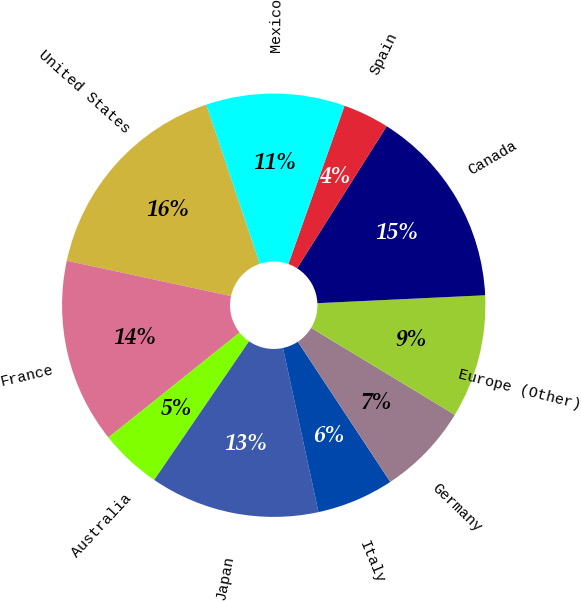<chart> <loc_0><loc_0><loc_500><loc_500><pie_chart><fcel>United States<fcel>France<fcel>Australia<fcel>Japan<fcel>Italy<fcel>Germany<fcel>Europe (Other)<fcel>Canada<fcel>Spain<fcel>Mexico<nl><fcel>16.47%<fcel>14.11%<fcel>4.71%<fcel>12.94%<fcel>5.89%<fcel>7.06%<fcel>9.41%<fcel>15.29%<fcel>3.53%<fcel>10.59%<nl></chart> 